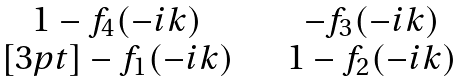<formula> <loc_0><loc_0><loc_500><loc_500>\begin{matrix} 1 - f _ { 4 } ( - i k ) \quad & - f _ { 3 } ( - i k ) \\ [ 3 p t ] - f _ { 1 } ( - i k ) \quad & 1 - f _ { 2 } ( - i k ) \end{matrix}</formula> 